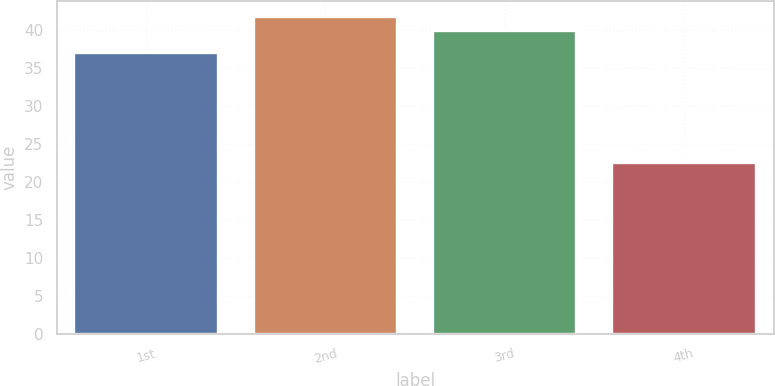Convert chart. <chart><loc_0><loc_0><loc_500><loc_500><bar_chart><fcel>1st<fcel>2nd<fcel>3rd<fcel>4th<nl><fcel>36.99<fcel>41.68<fcel>39.9<fcel>22.5<nl></chart> 